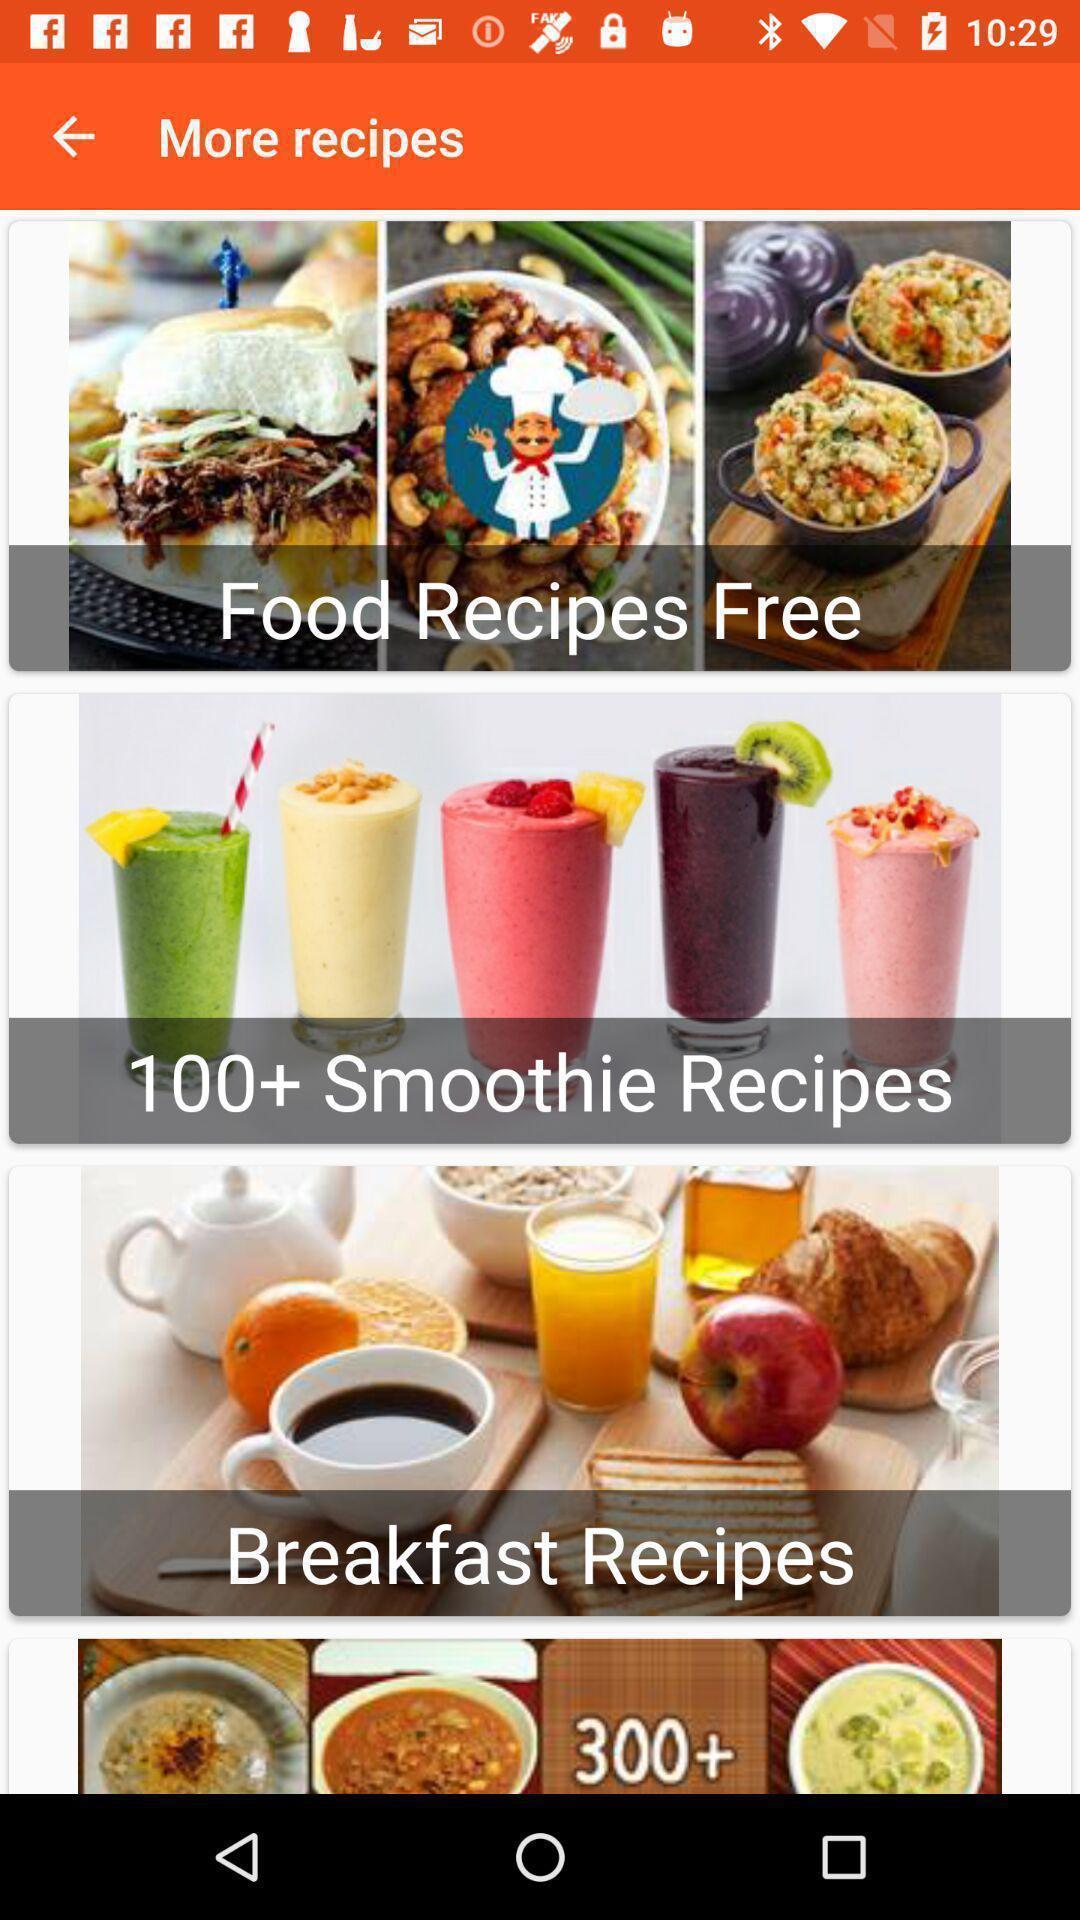Describe the visual elements of this screenshot. Showing different recipes in an cooking application. 